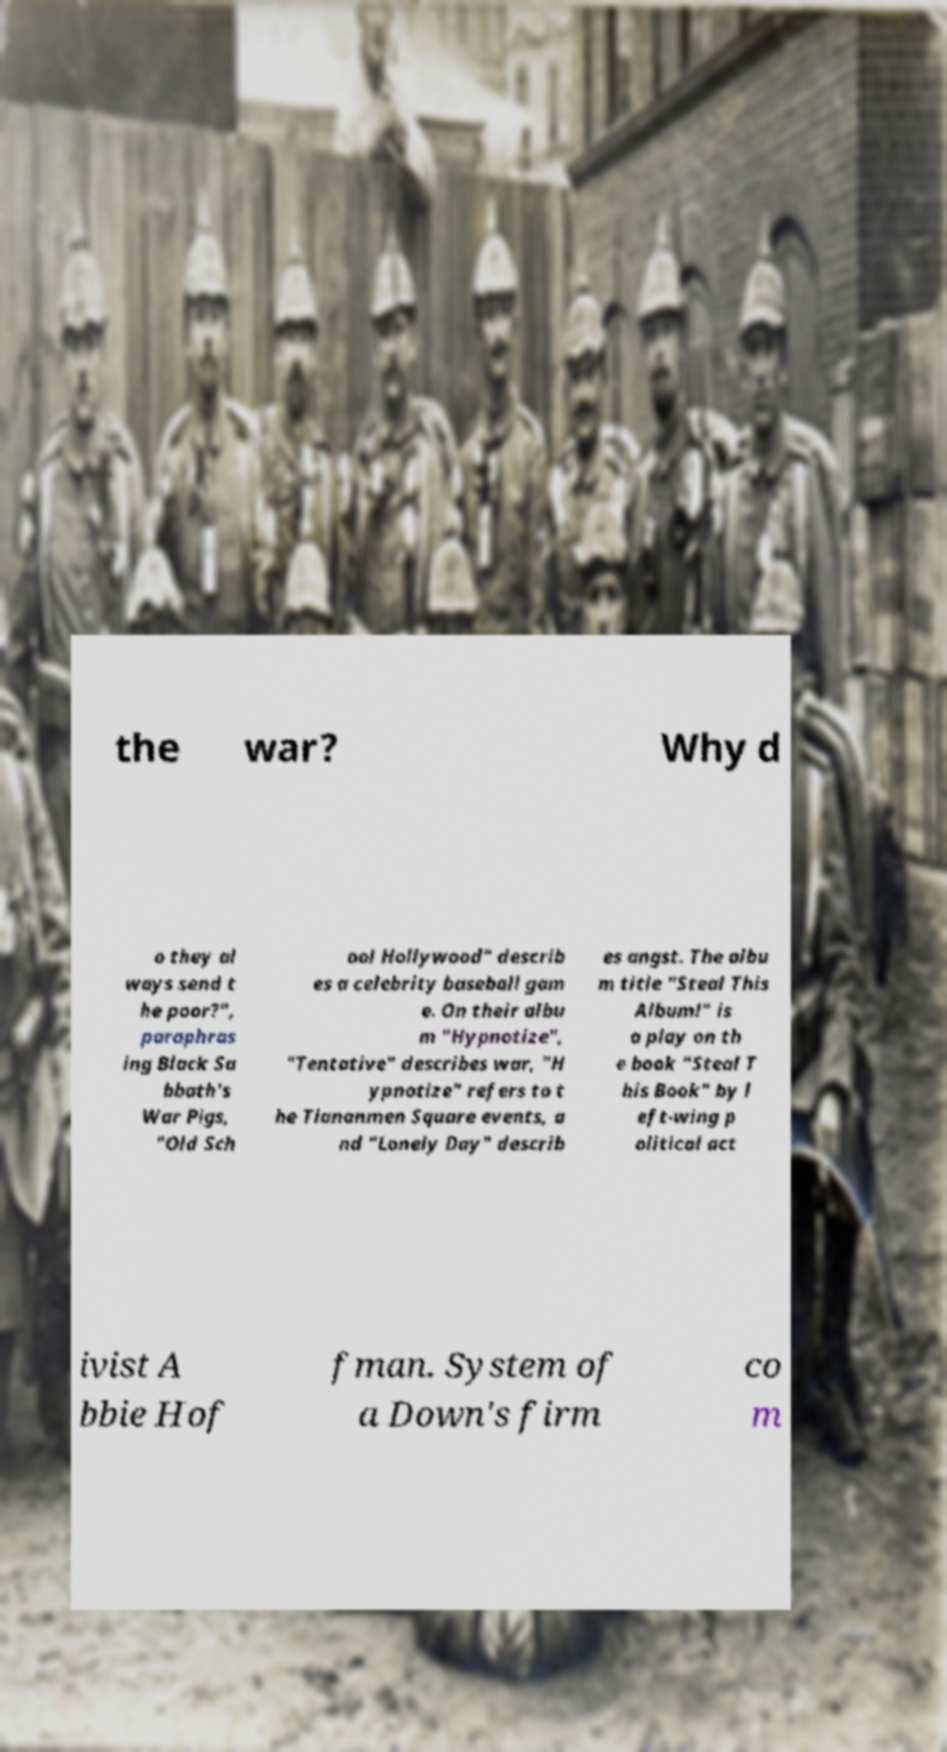Please identify and transcribe the text found in this image. the war? Why d o they al ways send t he poor?", paraphras ing Black Sa bbath's War Pigs, "Old Sch ool Hollywood" describ es a celebrity baseball gam e. On their albu m "Hypnotize", "Tentative" describes war, "H ypnotize" refers to t he Tiananmen Square events, a nd "Lonely Day" describ es angst. The albu m title "Steal This Album!" is a play on th e book "Steal T his Book" by l eft-wing p olitical act ivist A bbie Hof fman. System of a Down's firm co m 